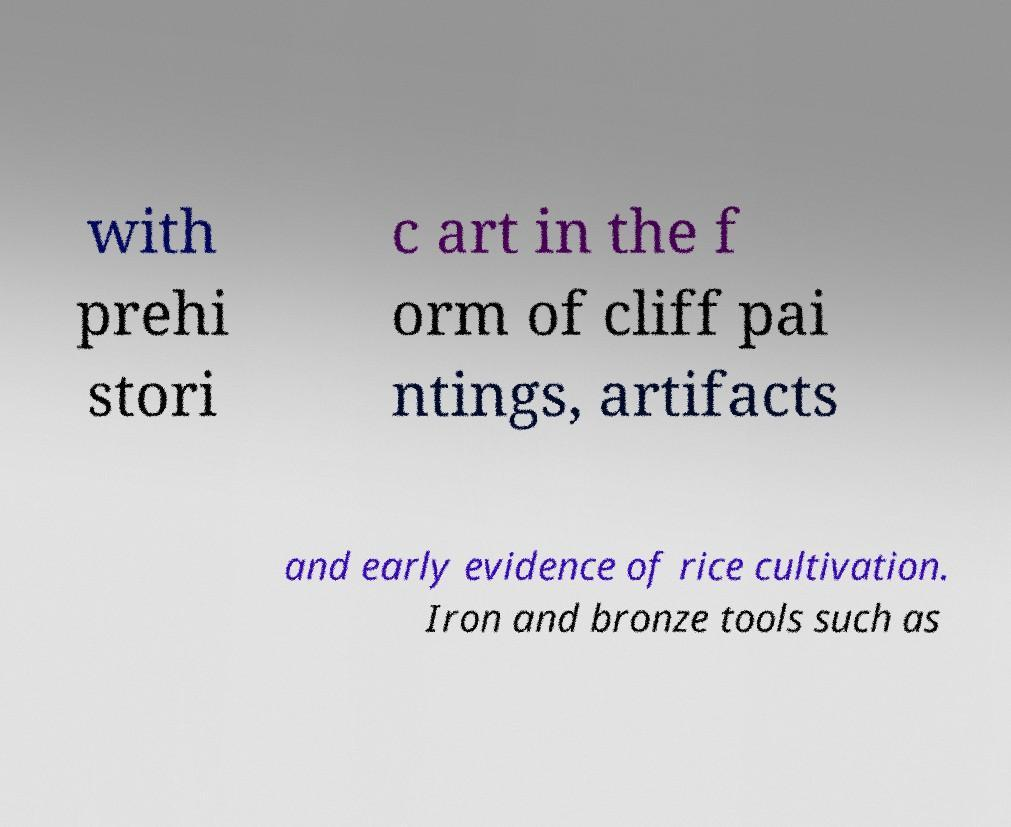For documentation purposes, I need the text within this image transcribed. Could you provide that? with prehi stori c art in the f orm of cliff pai ntings, artifacts and early evidence of rice cultivation. Iron and bronze tools such as 